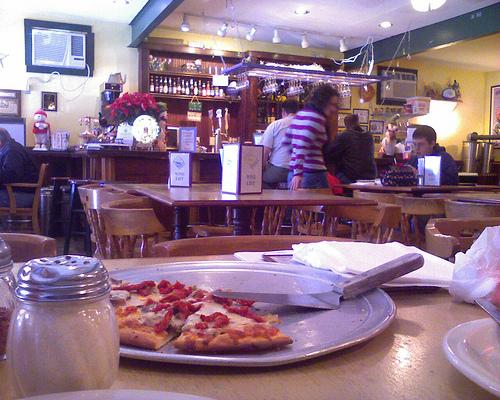What does the tool near the pizza do?

Choices:
A) cook pizza
B) destroy pizza
C) scoop pizza
D) store pizza scoop pizza 